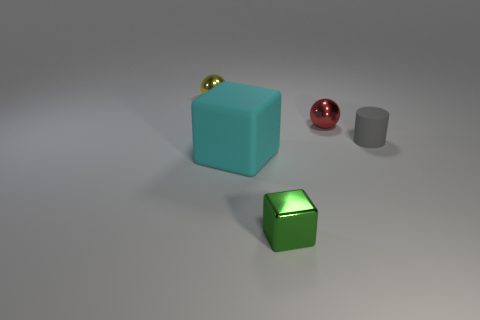Subtract 1 cylinders. How many cylinders are left? 0 Subtract all brown cylinders. Subtract all red cubes. How many cylinders are left? 1 Add 4 small blue matte objects. How many objects exist? 9 Subtract all blocks. How many objects are left? 3 Add 5 big purple metallic balls. How many big purple metallic balls exist? 5 Subtract 0 blue cylinders. How many objects are left? 5 Subtract all gray cylinders. Subtract all small cyan balls. How many objects are left? 4 Add 2 green metallic objects. How many green metallic objects are left? 3 